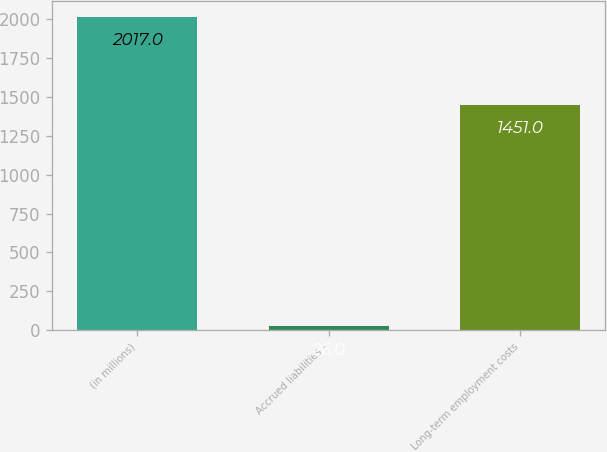Convert chart. <chart><loc_0><loc_0><loc_500><loc_500><bar_chart><fcel>(in millions)<fcel>Accrued liabilities -<fcel>Long-term employment costs<nl><fcel>2017<fcel>26<fcel>1451<nl></chart> 